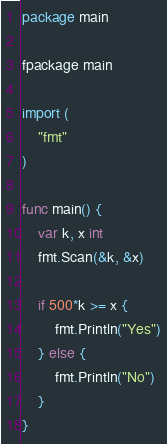<code> <loc_0><loc_0><loc_500><loc_500><_Go_>package main

fpackage main

import (
	"fmt"
)

func main() {
	var k, x int
	fmt.Scan(&k, &x)

	if 500*k >= x {
		fmt.Println("Yes")
	} else {
		fmt.Println("No")
	}
}</code> 